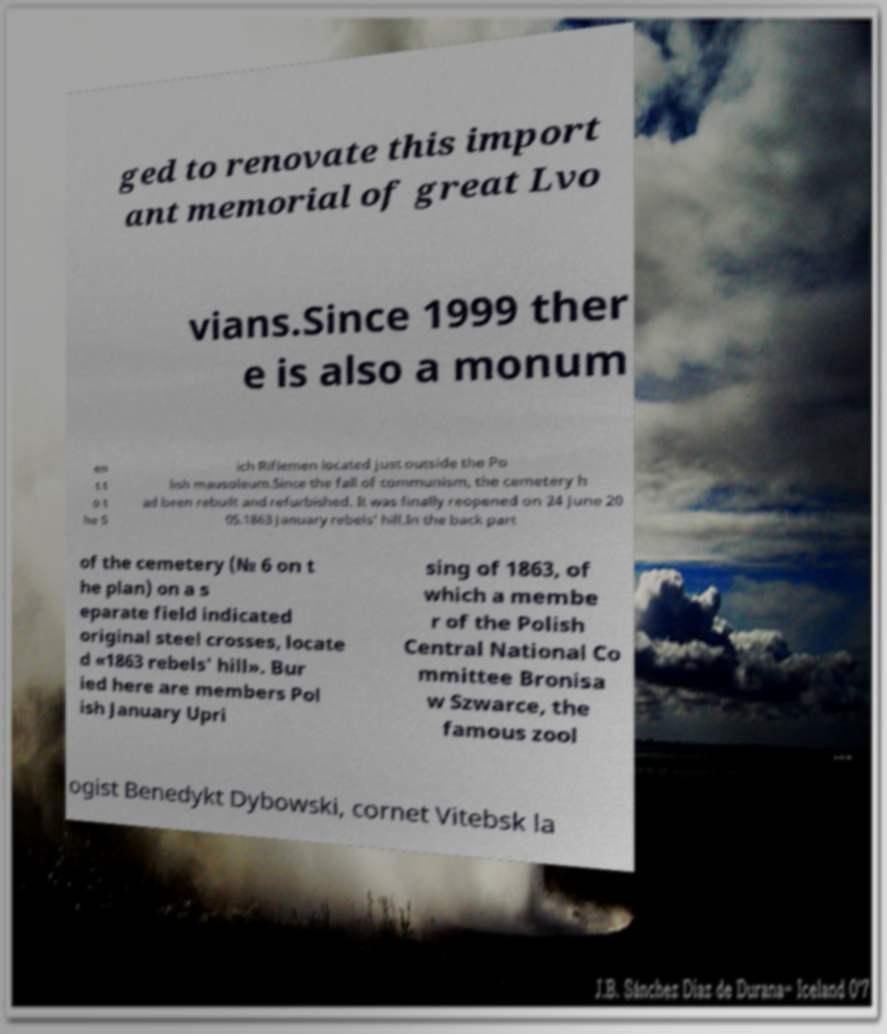Could you extract and type out the text from this image? ged to renovate this import ant memorial of great Lvo vians.Since 1999 ther e is also a monum en t t o t he S ich Riflemen located just outside the Po lish mausoleum.Since the fall of communism, the cemetery h ad been rebuilt and refurbished. It was finally reopened on 24 June 20 05.1863 January rebels' hill.In the back part of the cemetery (№ 6 on t he plan) on a s eparate field indicated original steel crosses, locate d «1863 rebels' hill». Bur ied here are members Pol ish January Upri sing of 1863, of which a membe r of the Polish Central National Co mmittee Bronisa w Szwarce, the famous zool ogist Benedykt Dybowski, cornet Vitebsk la 